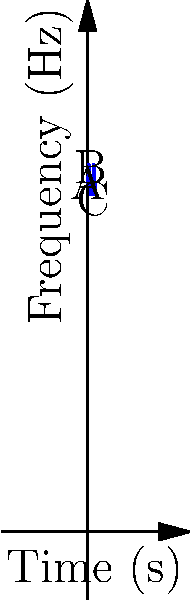The graph represents the sound wave frequency of a clarinet note over time. What is the approximate difference in frequency (in Hz) between the highest point B and the lowest point C of the wave? To find the difference in frequency between the highest and lowest points:

1. Identify the highest point (B) and lowest point (C) on the graph.
2. Estimate the y-coordinate (frequency) for each point:
   Point B (highest): approximately 460 Hz
   Point C (lowest): approximately 420 Hz
3. Calculate the difference:
   $460 \text{ Hz} - 420 \text{ Hz} = 40 \text{ Hz}$

The difference in frequency between the highest and lowest points is about 40 Hz.
Answer: 40 Hz 